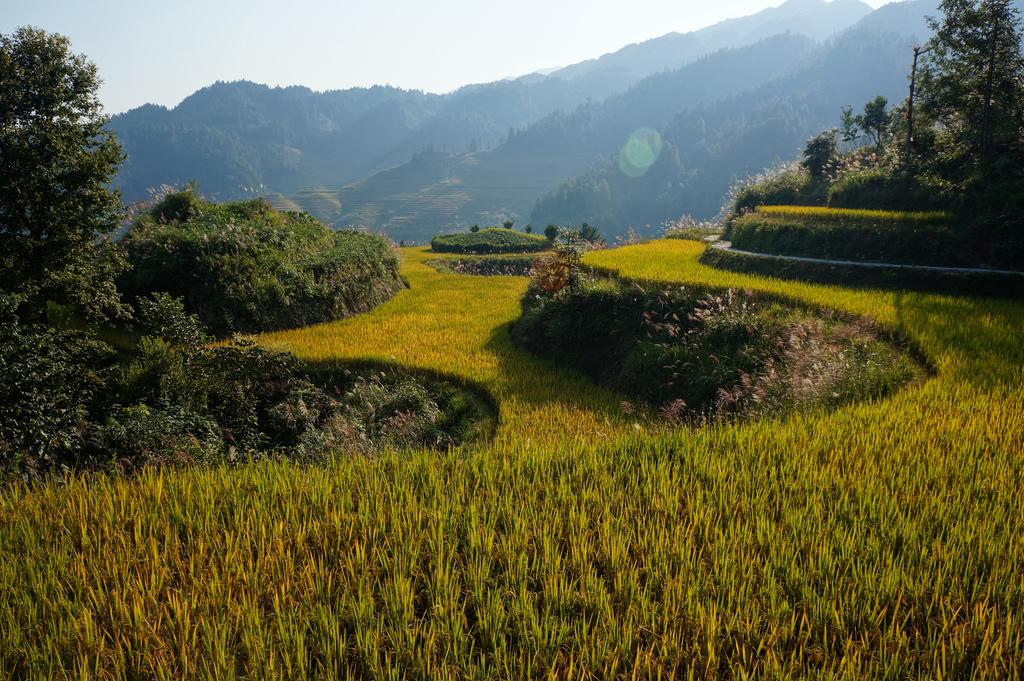What type of landscape is depicted in the image? The image contains fields, trees, and hills covered with trees. Can you describe the vegetation in the image? There are trees and a plant visible in the image. What is the primary feature in the middle of the image? There are hills covered with trees in the middle of the image. What is visible at the top of the image? The sky is visible at the top of the image. What type of crop can be seen in the foreground of the image? There are paddy fields in the foreground of the image. What is the value of the anger expressed by the plant in the image? There is no indication of anger or value in the image, as it features a landscape with fields, trees, and paddy fields. 